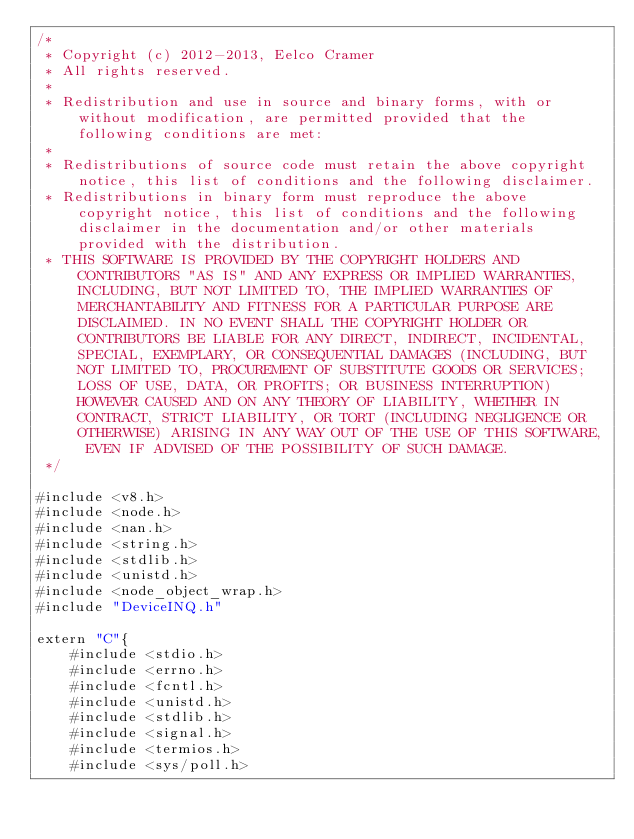Convert code to text. <code><loc_0><loc_0><loc_500><loc_500><_ObjectiveC_>/*
 * Copyright (c) 2012-2013, Eelco Cramer
 * All rights reserved.
 *
 * Redistribution and use in source and binary forms, with or without modification, are permitted provided that the following conditions are met:
 *
 * Redistributions of source code must retain the above copyright notice, this list of conditions and the following disclaimer.
 * Redistributions in binary form must reproduce the above copyright notice, this list of conditions and the following disclaimer in the documentation and/or other materials provided with the distribution.
 * THIS SOFTWARE IS PROVIDED BY THE COPYRIGHT HOLDERS AND CONTRIBUTORS "AS IS" AND ANY EXPRESS OR IMPLIED WARRANTIES, INCLUDING, BUT NOT LIMITED TO, THE IMPLIED WARRANTIES OF MERCHANTABILITY AND FITNESS FOR A PARTICULAR PURPOSE ARE DISCLAIMED. IN NO EVENT SHALL THE COPYRIGHT HOLDER OR CONTRIBUTORS BE LIABLE FOR ANY DIRECT, INDIRECT, INCIDENTAL, SPECIAL, EXEMPLARY, OR CONSEQUENTIAL DAMAGES (INCLUDING, BUT NOT LIMITED TO, PROCUREMENT OF SUBSTITUTE GOODS OR SERVICES; LOSS OF USE, DATA, OR PROFITS; OR BUSINESS INTERRUPTION) HOWEVER CAUSED AND ON ANY THEORY OF LIABILITY, WHETHER IN CONTRACT, STRICT LIABILITY, OR TORT (INCLUDING NEGLIGENCE OR OTHERWISE) ARISING IN ANY WAY OUT OF THE USE OF THIS SOFTWARE, EVEN IF ADVISED OF THE POSSIBILITY OF SUCH DAMAGE.
 */

#include <v8.h>
#include <node.h>
#include <nan.h>
#include <string.h>
#include <stdlib.h>
#include <unistd.h>
#include <node_object_wrap.h>
#include "DeviceINQ.h"

extern "C"{
    #include <stdio.h>
    #include <errno.h>
    #include <fcntl.h>
    #include <unistd.h>
    #include <stdlib.h>
    #include <signal.h>
    #include <termios.h>
    #include <sys/poll.h></code> 